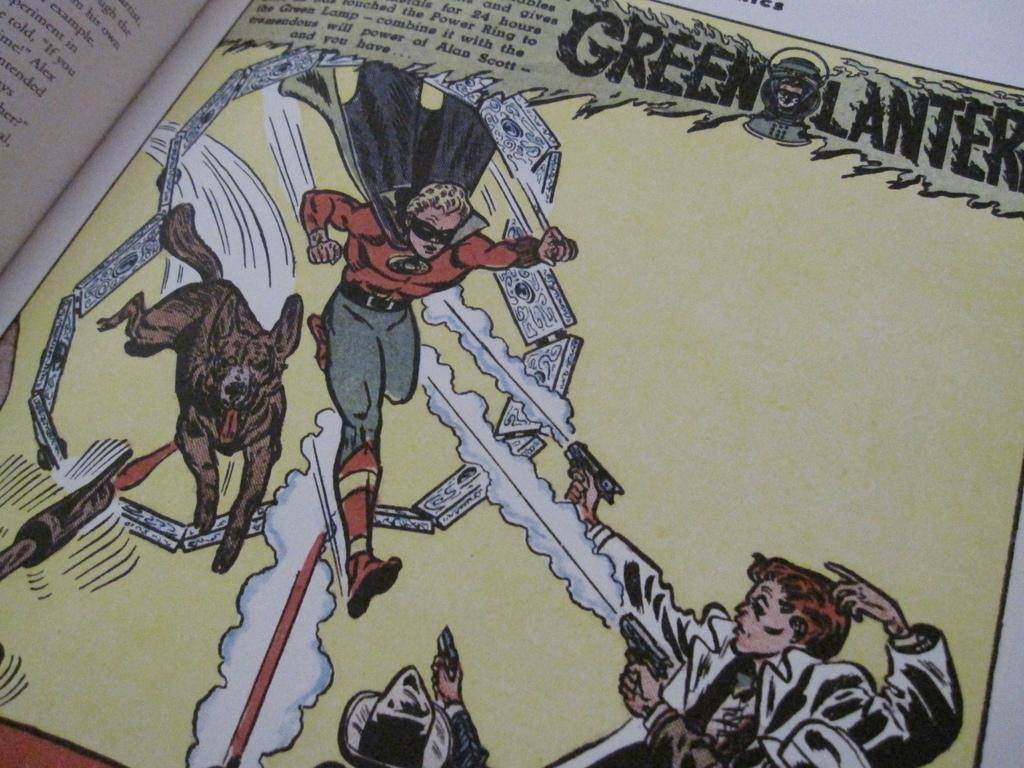What is present in the image? There is a book in the image. What type of content does the book contain? The book contains text and cartoons. What color is the honey dripping from the sweater in the image? There is no honey or sweater present in the image; it only contains a book with text and cartoons. 